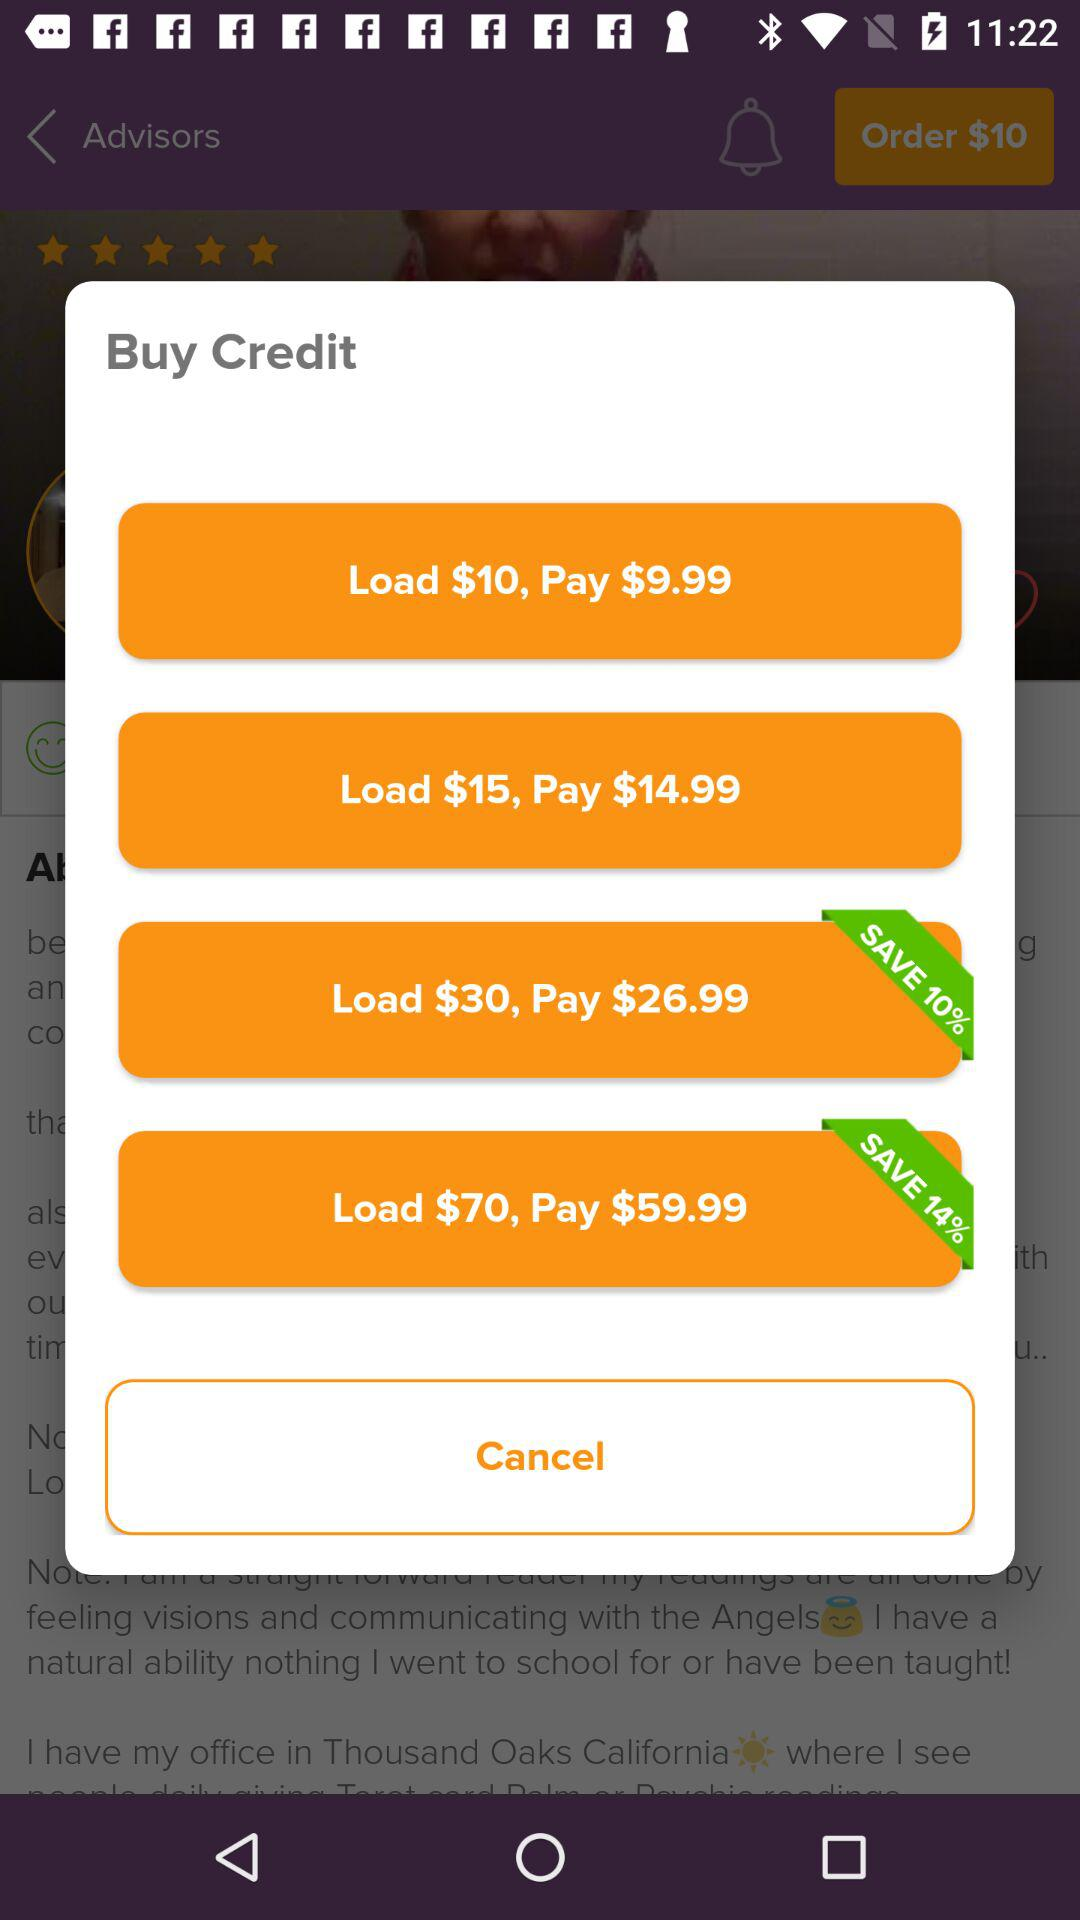What is the cost of load $14?
When the provided information is insufficient, respond with <no answer>. <no answer> 